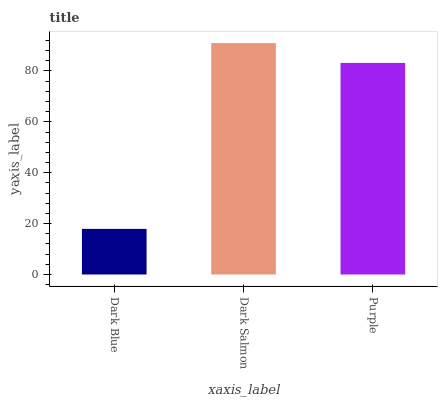Is Dark Blue the minimum?
Answer yes or no. Yes. Is Dark Salmon the maximum?
Answer yes or no. Yes. Is Purple the minimum?
Answer yes or no. No. Is Purple the maximum?
Answer yes or no. No. Is Dark Salmon greater than Purple?
Answer yes or no. Yes. Is Purple less than Dark Salmon?
Answer yes or no. Yes. Is Purple greater than Dark Salmon?
Answer yes or no. No. Is Dark Salmon less than Purple?
Answer yes or no. No. Is Purple the high median?
Answer yes or no. Yes. Is Purple the low median?
Answer yes or no. Yes. Is Dark Blue the high median?
Answer yes or no. No. Is Dark Blue the low median?
Answer yes or no. No. 